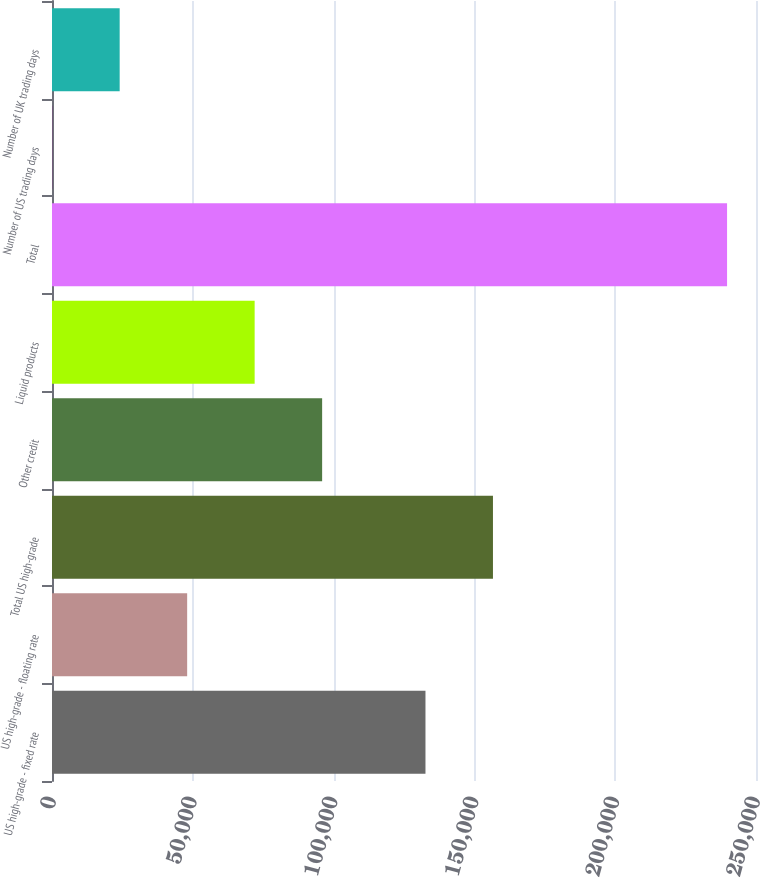Convert chart to OTSL. <chart><loc_0><loc_0><loc_500><loc_500><bar_chart><fcel>US high-grade - fixed rate<fcel>US high-grade - floating rate<fcel>Total US high-grade<fcel>Other credit<fcel>Liquid products<fcel>Total<fcel>Number of US trading days<fcel>Number of UK trading days<nl><fcel>132625<fcel>47996.2<fcel>156591<fcel>95928.4<fcel>71962.3<fcel>239725<fcel>64<fcel>24030.1<nl></chart> 